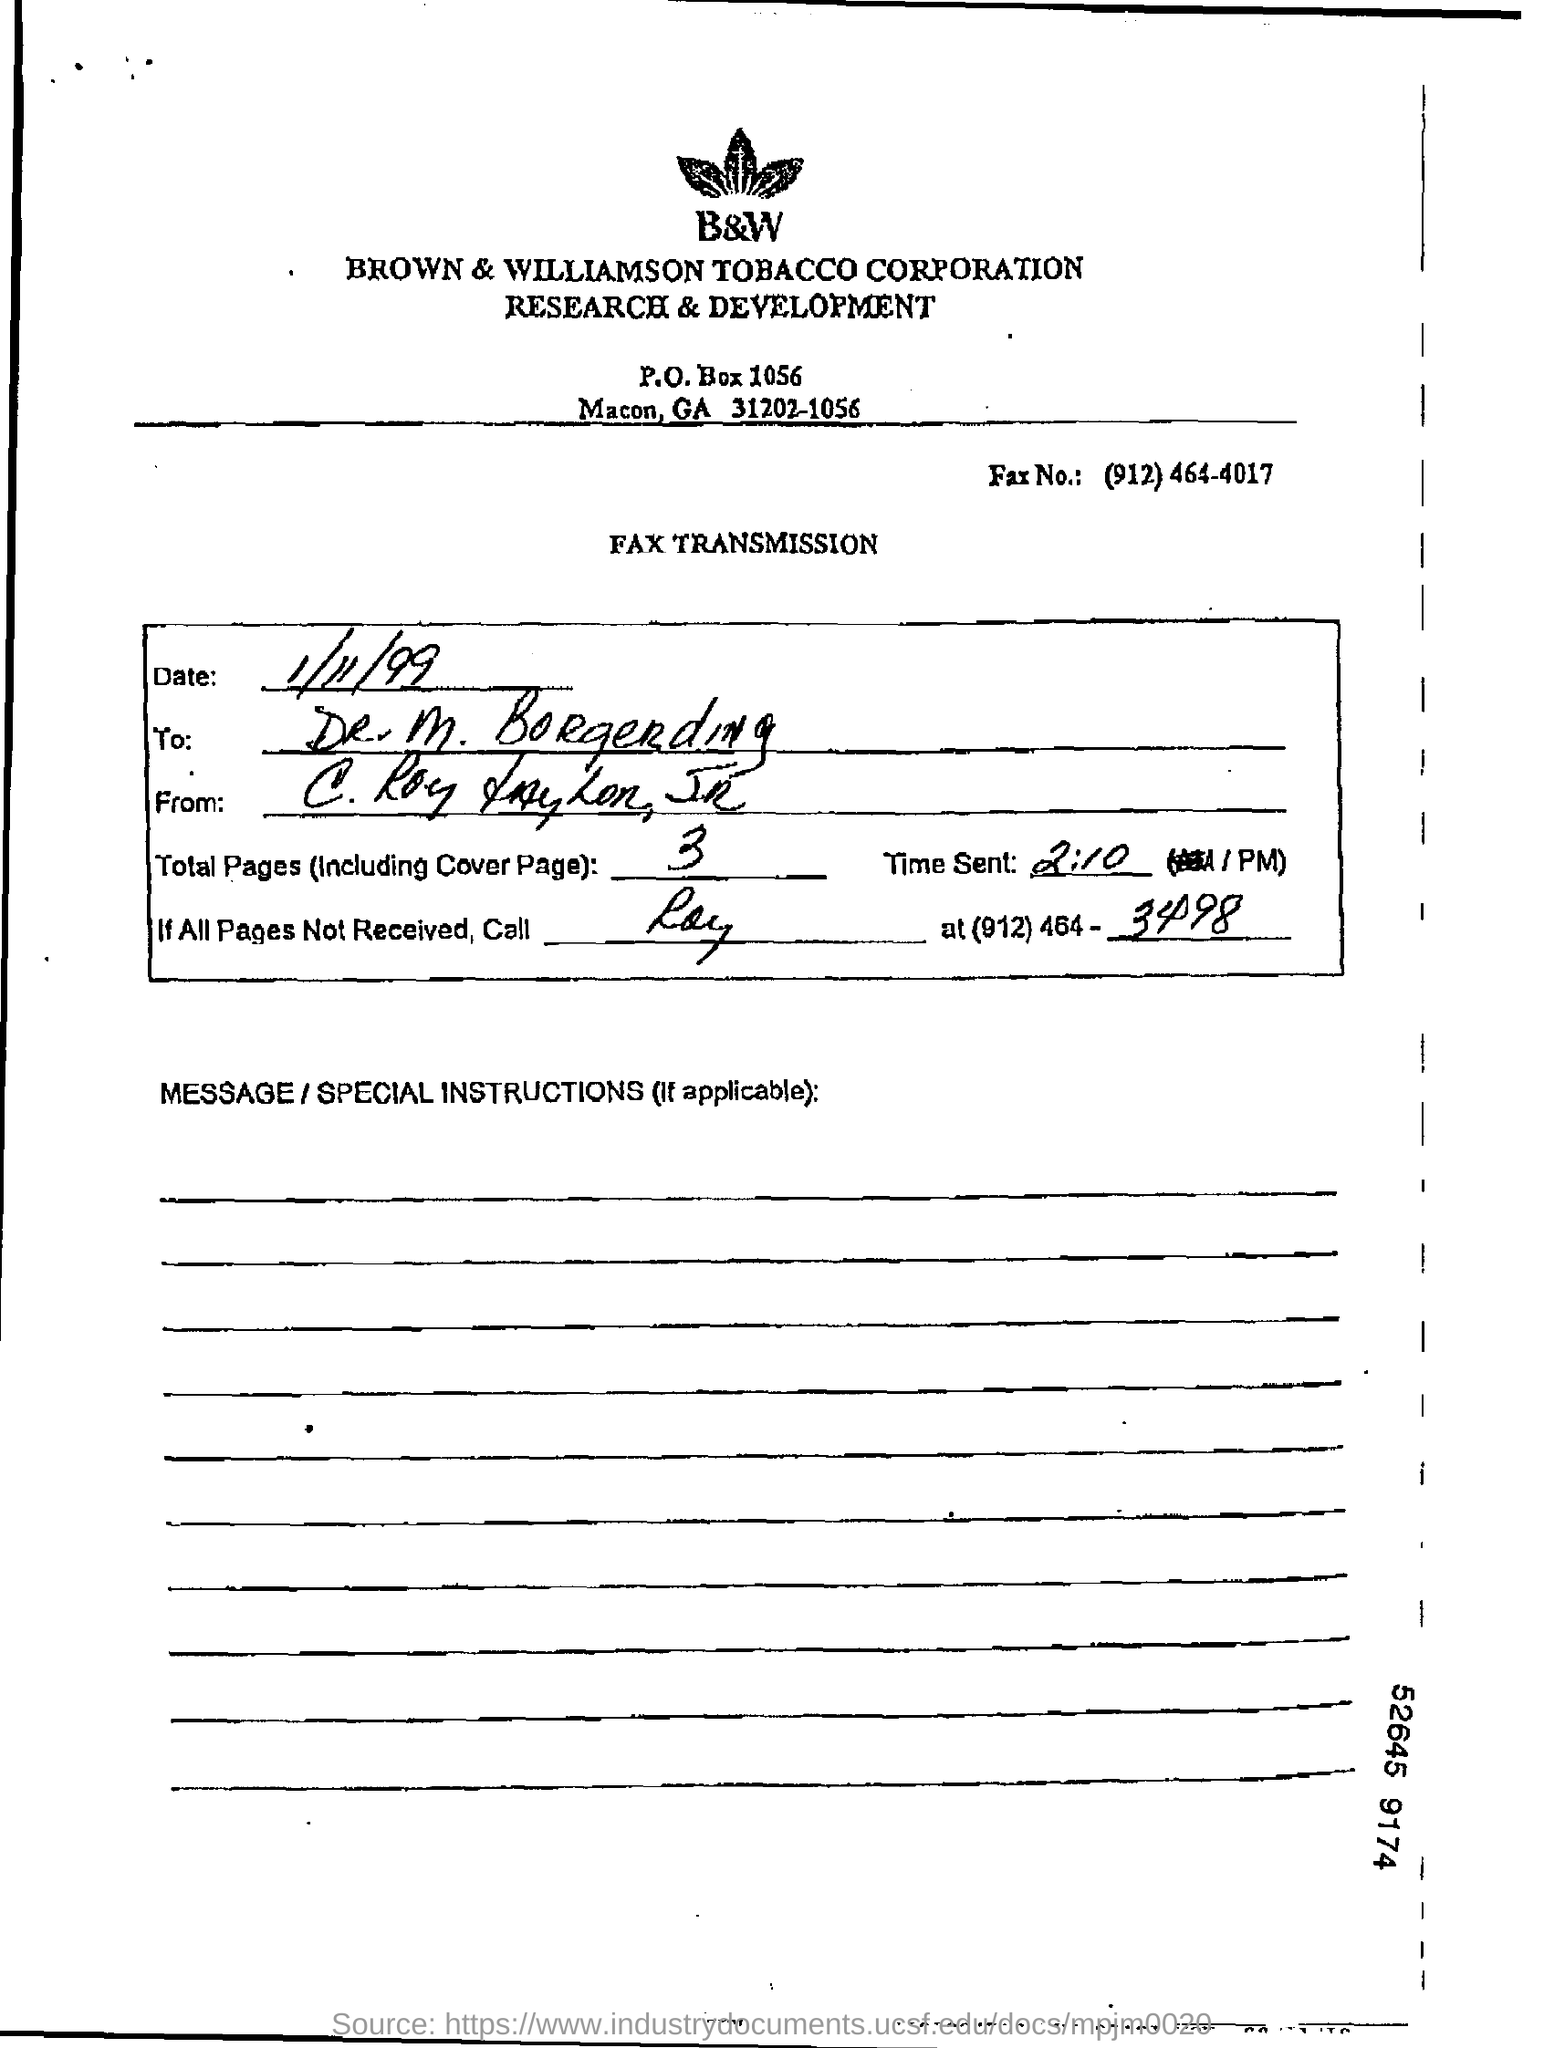What is the total no of pages in the fax including cover page?
Make the answer very short. 3. What is the Fax Number ?
Your answer should be compact. (912) 464-4017. What is the full form of B&W ?
Ensure brevity in your answer.  Brown & Williamson. What are the total number of pages (Including cover page) ?
Keep it short and to the point. 3. 